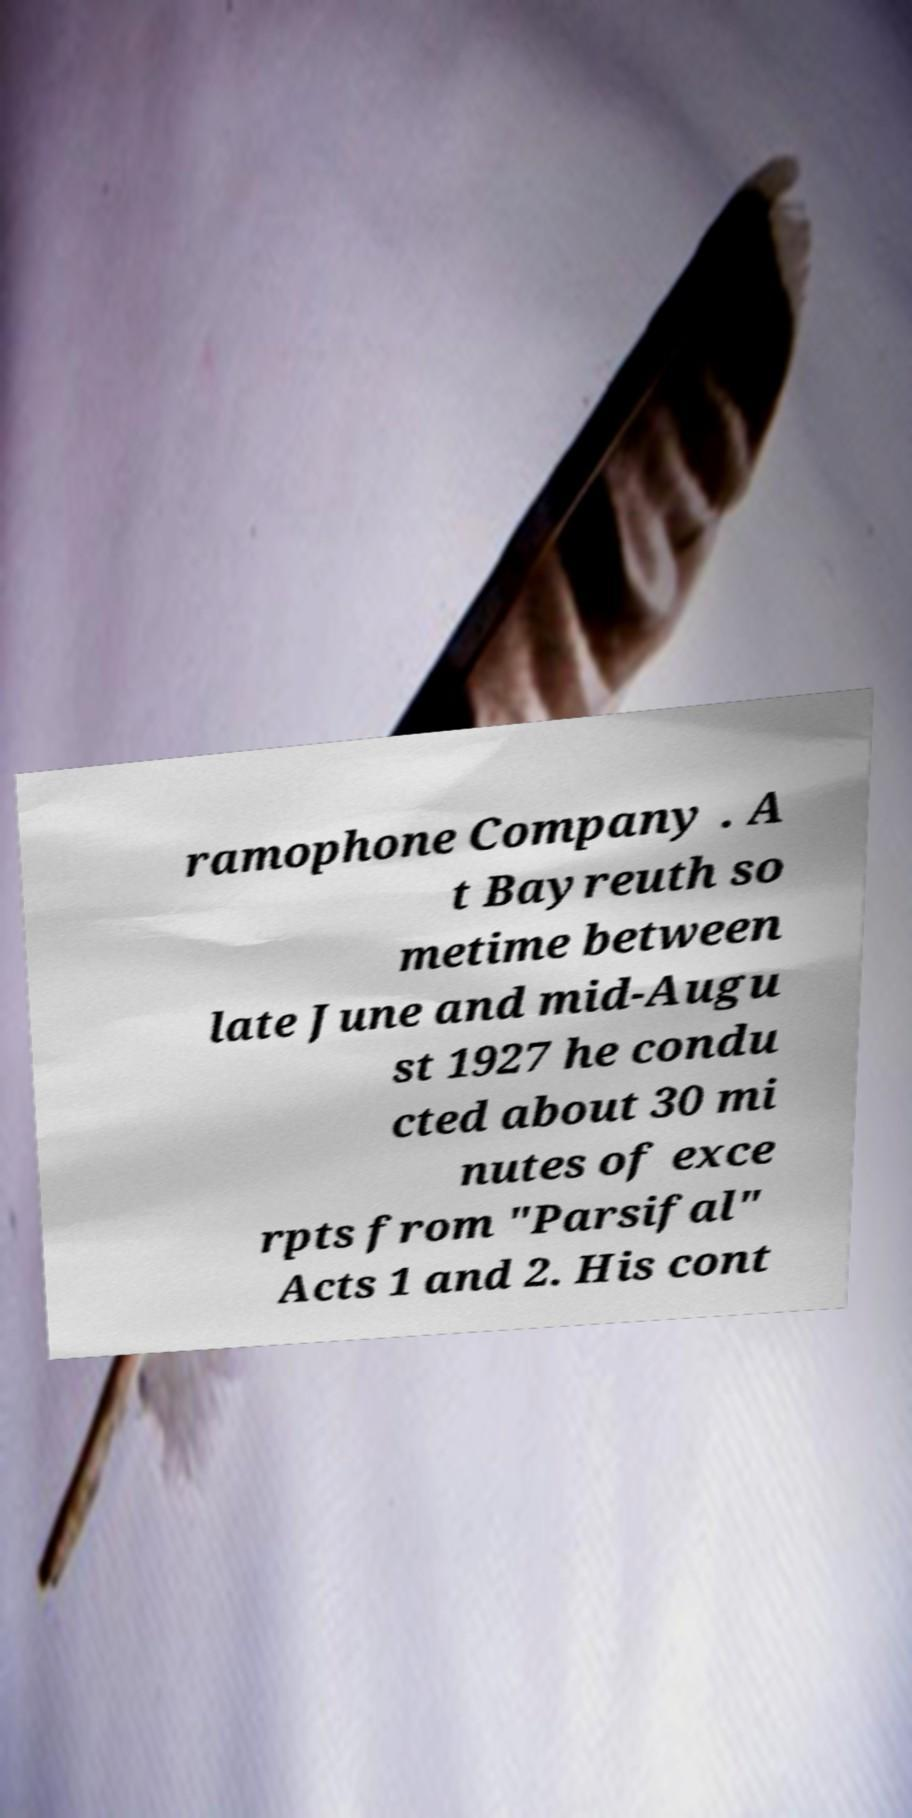Can you read and provide the text displayed in the image?This photo seems to have some interesting text. Can you extract and type it out for me? ramophone Company . A t Bayreuth so metime between late June and mid-Augu st 1927 he condu cted about 30 mi nutes of exce rpts from "Parsifal" Acts 1 and 2. His cont 